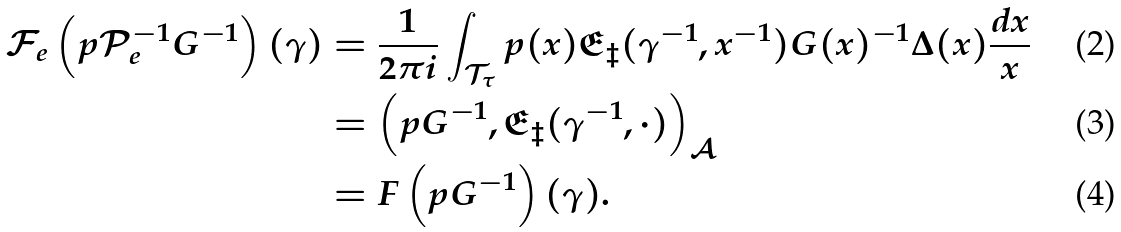<formula> <loc_0><loc_0><loc_500><loc_500>\mathcal { F } _ { e } \left ( p \mathcal { P } _ { e } ^ { - 1 } G ^ { - 1 } \right ) ( \gamma ) & = \frac { 1 } { 2 \pi i } \int _ { \mathcal { T } _ { \tau } } p ( x ) \mathfrak { E } _ { \ddagger } ( \gamma ^ { - 1 } , x ^ { - 1 } ) G ( x ) ^ { - 1 } \Delta ( x ) \frac { d x } { x } \\ & = \left ( p G ^ { - 1 } , \mathfrak { E } _ { \ddagger } ( \gamma ^ { - 1 } , \cdot ) \right ) _ { \mathcal { A } } \\ & = F \left ( p G ^ { - 1 } \right ) ( \gamma ) .</formula> 